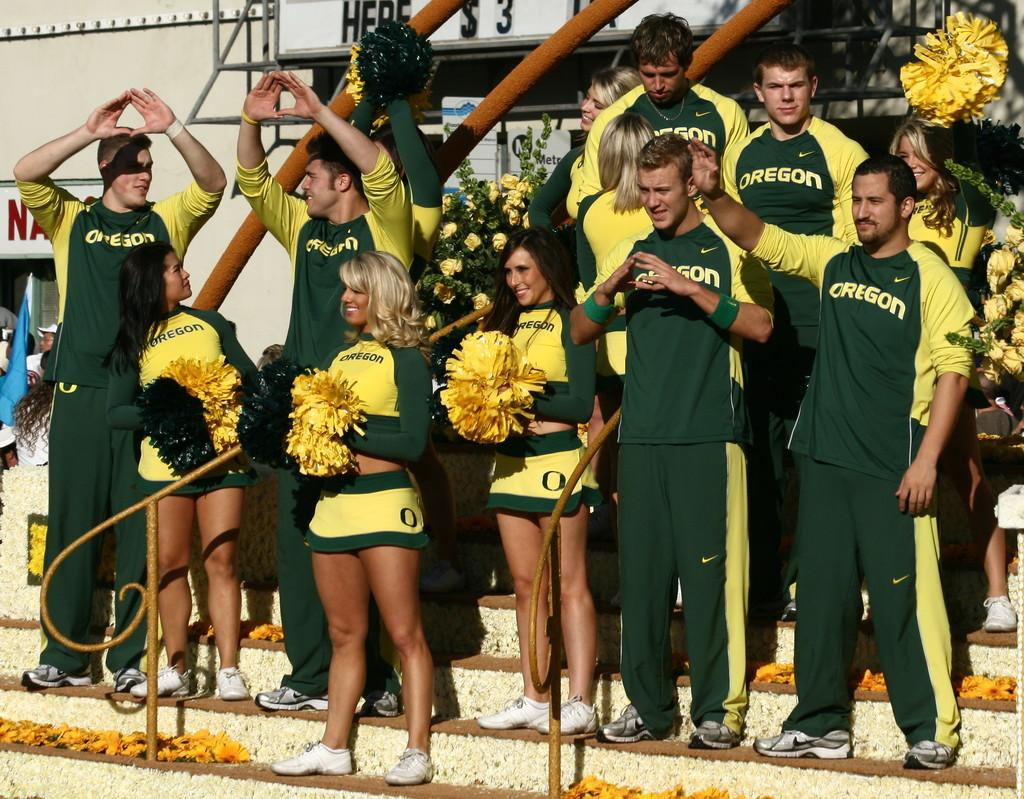<image>
Share a concise interpretation of the image provided. The group of students represent the college Oregon. 